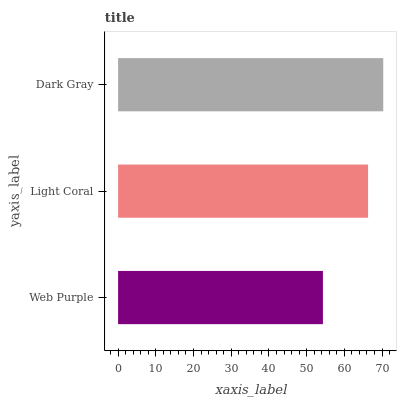Is Web Purple the minimum?
Answer yes or no. Yes. Is Dark Gray the maximum?
Answer yes or no. Yes. Is Light Coral the minimum?
Answer yes or no. No. Is Light Coral the maximum?
Answer yes or no. No. Is Light Coral greater than Web Purple?
Answer yes or no. Yes. Is Web Purple less than Light Coral?
Answer yes or no. Yes. Is Web Purple greater than Light Coral?
Answer yes or no. No. Is Light Coral less than Web Purple?
Answer yes or no. No. Is Light Coral the high median?
Answer yes or no. Yes. Is Light Coral the low median?
Answer yes or no. Yes. Is Dark Gray the high median?
Answer yes or no. No. Is Web Purple the low median?
Answer yes or no. No. 